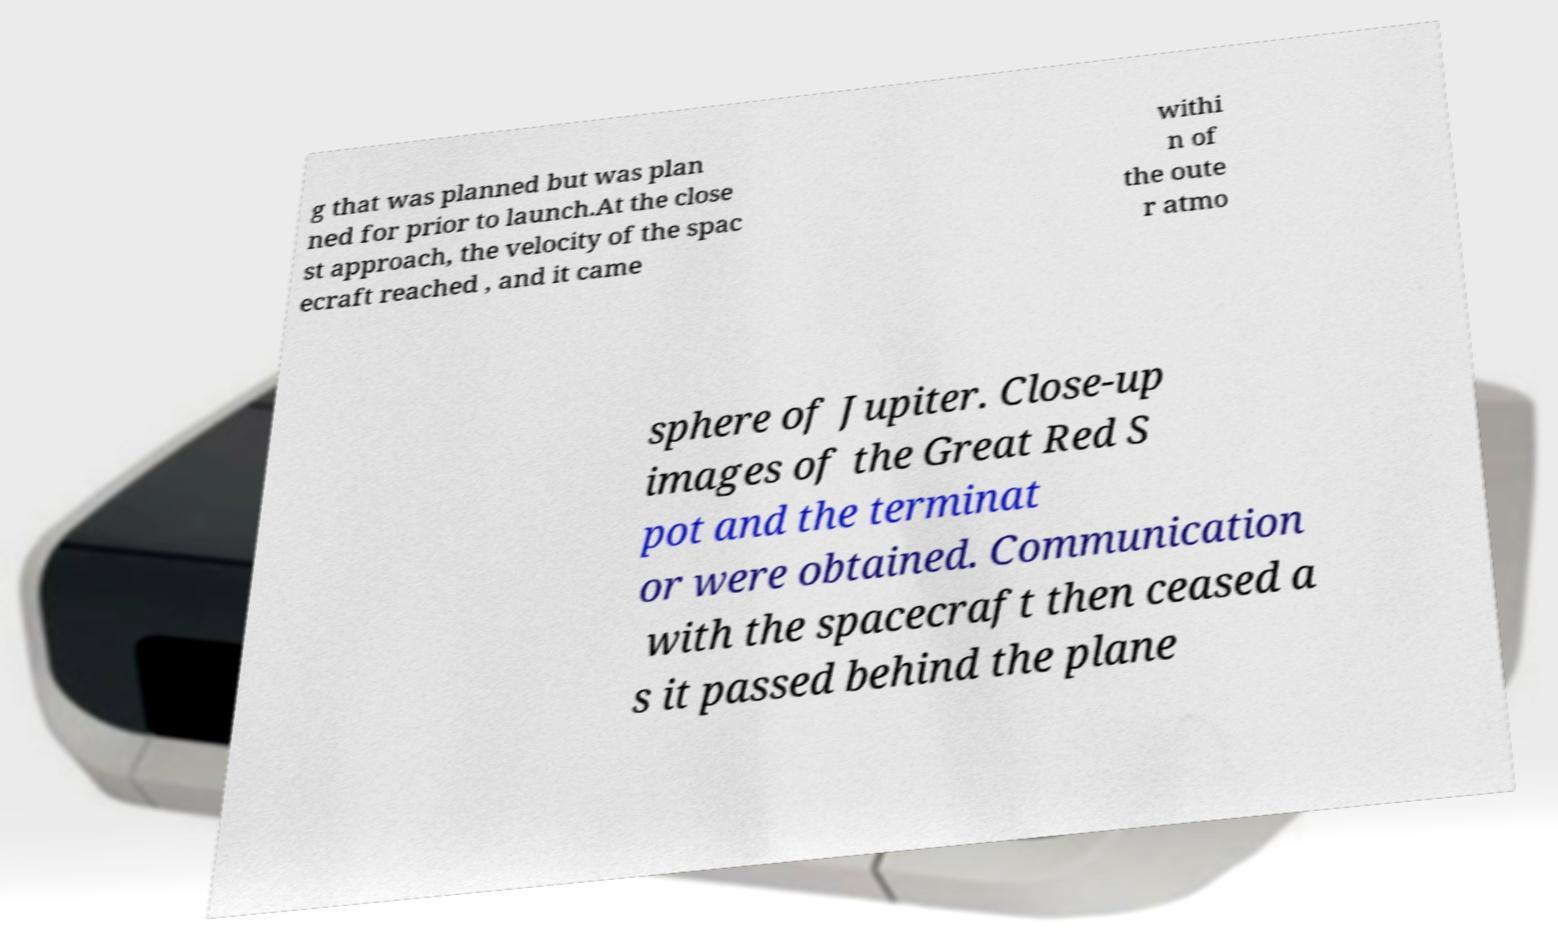Could you extract and type out the text from this image? g that was planned but was plan ned for prior to launch.At the close st approach, the velocity of the spac ecraft reached , and it came withi n of the oute r atmo sphere of Jupiter. Close-up images of the Great Red S pot and the terminat or were obtained. Communication with the spacecraft then ceased a s it passed behind the plane 